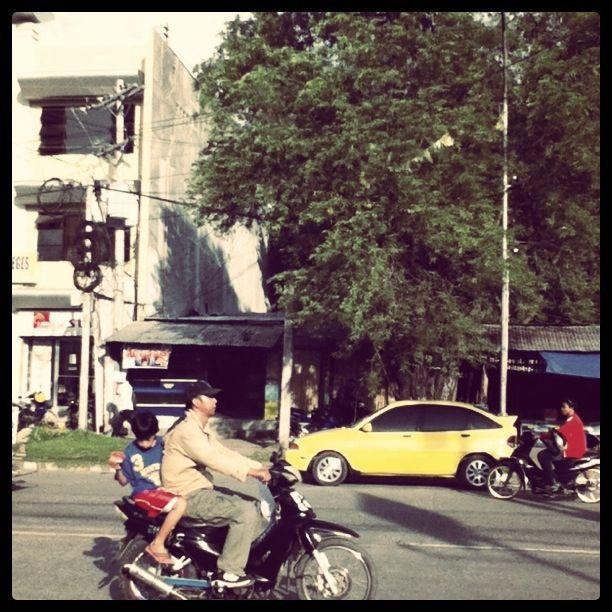How many cars can be seen?
Give a very brief answer. 1. How many motorcycles are there?
Give a very brief answer. 2. How many people are visible?
Give a very brief answer. 2. How many zebras have stripes?
Give a very brief answer. 0. 